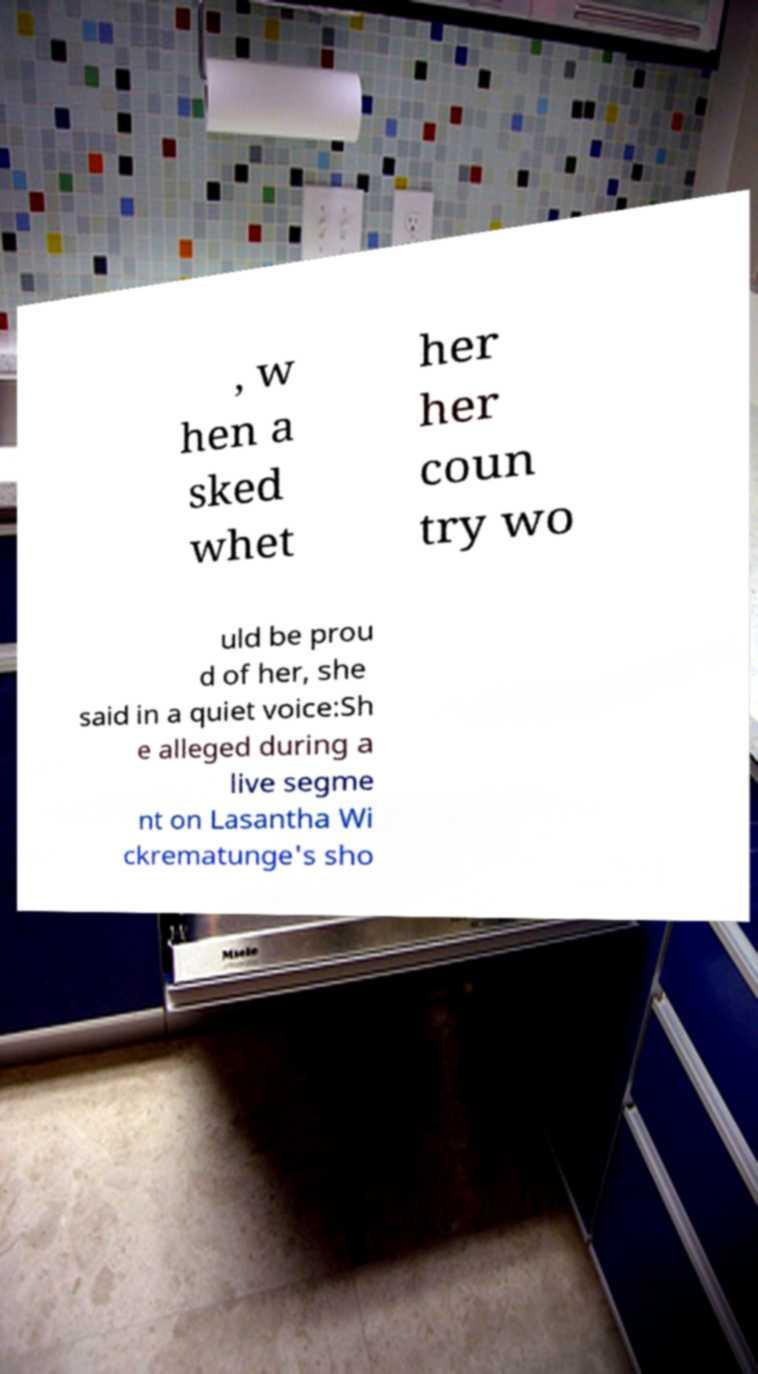What messages or text are displayed in this image? I need them in a readable, typed format. , w hen a sked whet her her coun try wo uld be prou d of her, she said in a quiet voice:Sh e alleged during a live segme nt on Lasantha Wi ckrematunge's sho 